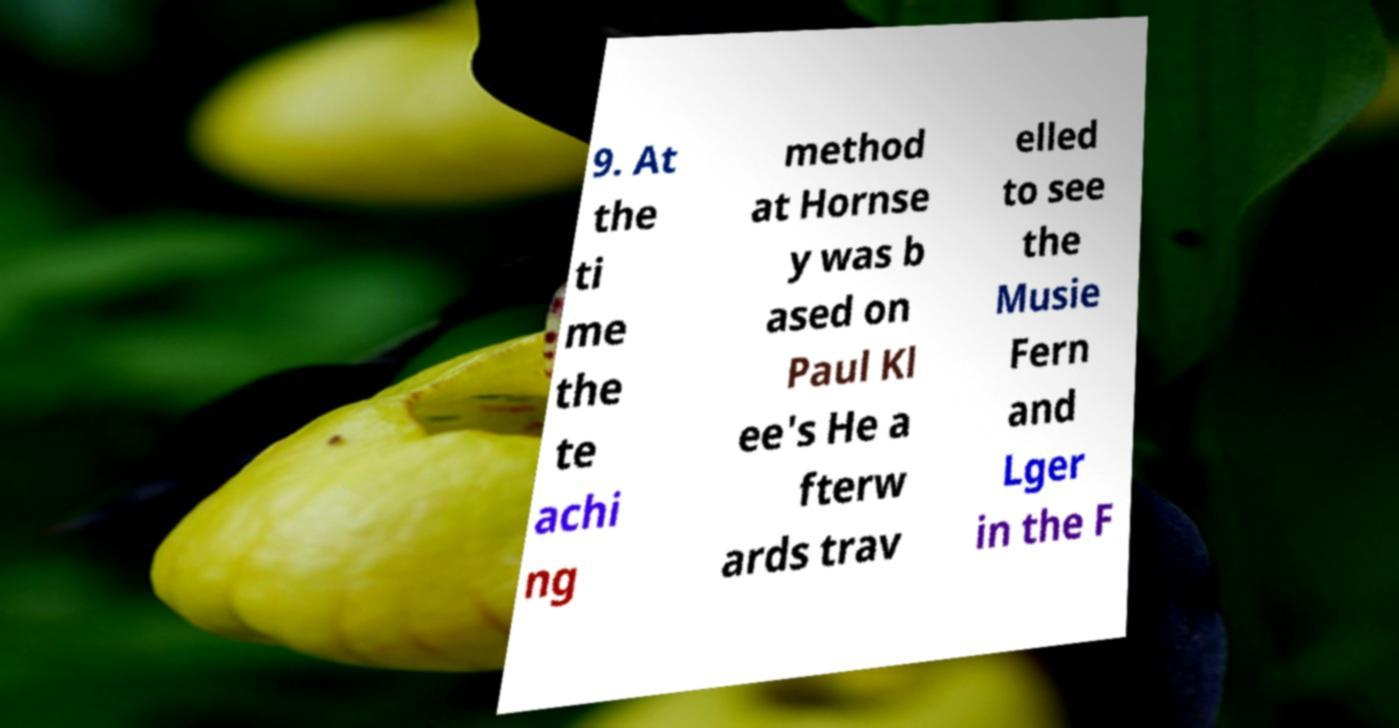Please identify and transcribe the text found in this image. 9. At the ti me the te achi ng method at Hornse y was b ased on Paul Kl ee's He a fterw ards trav elled to see the Musie Fern and Lger in the F 